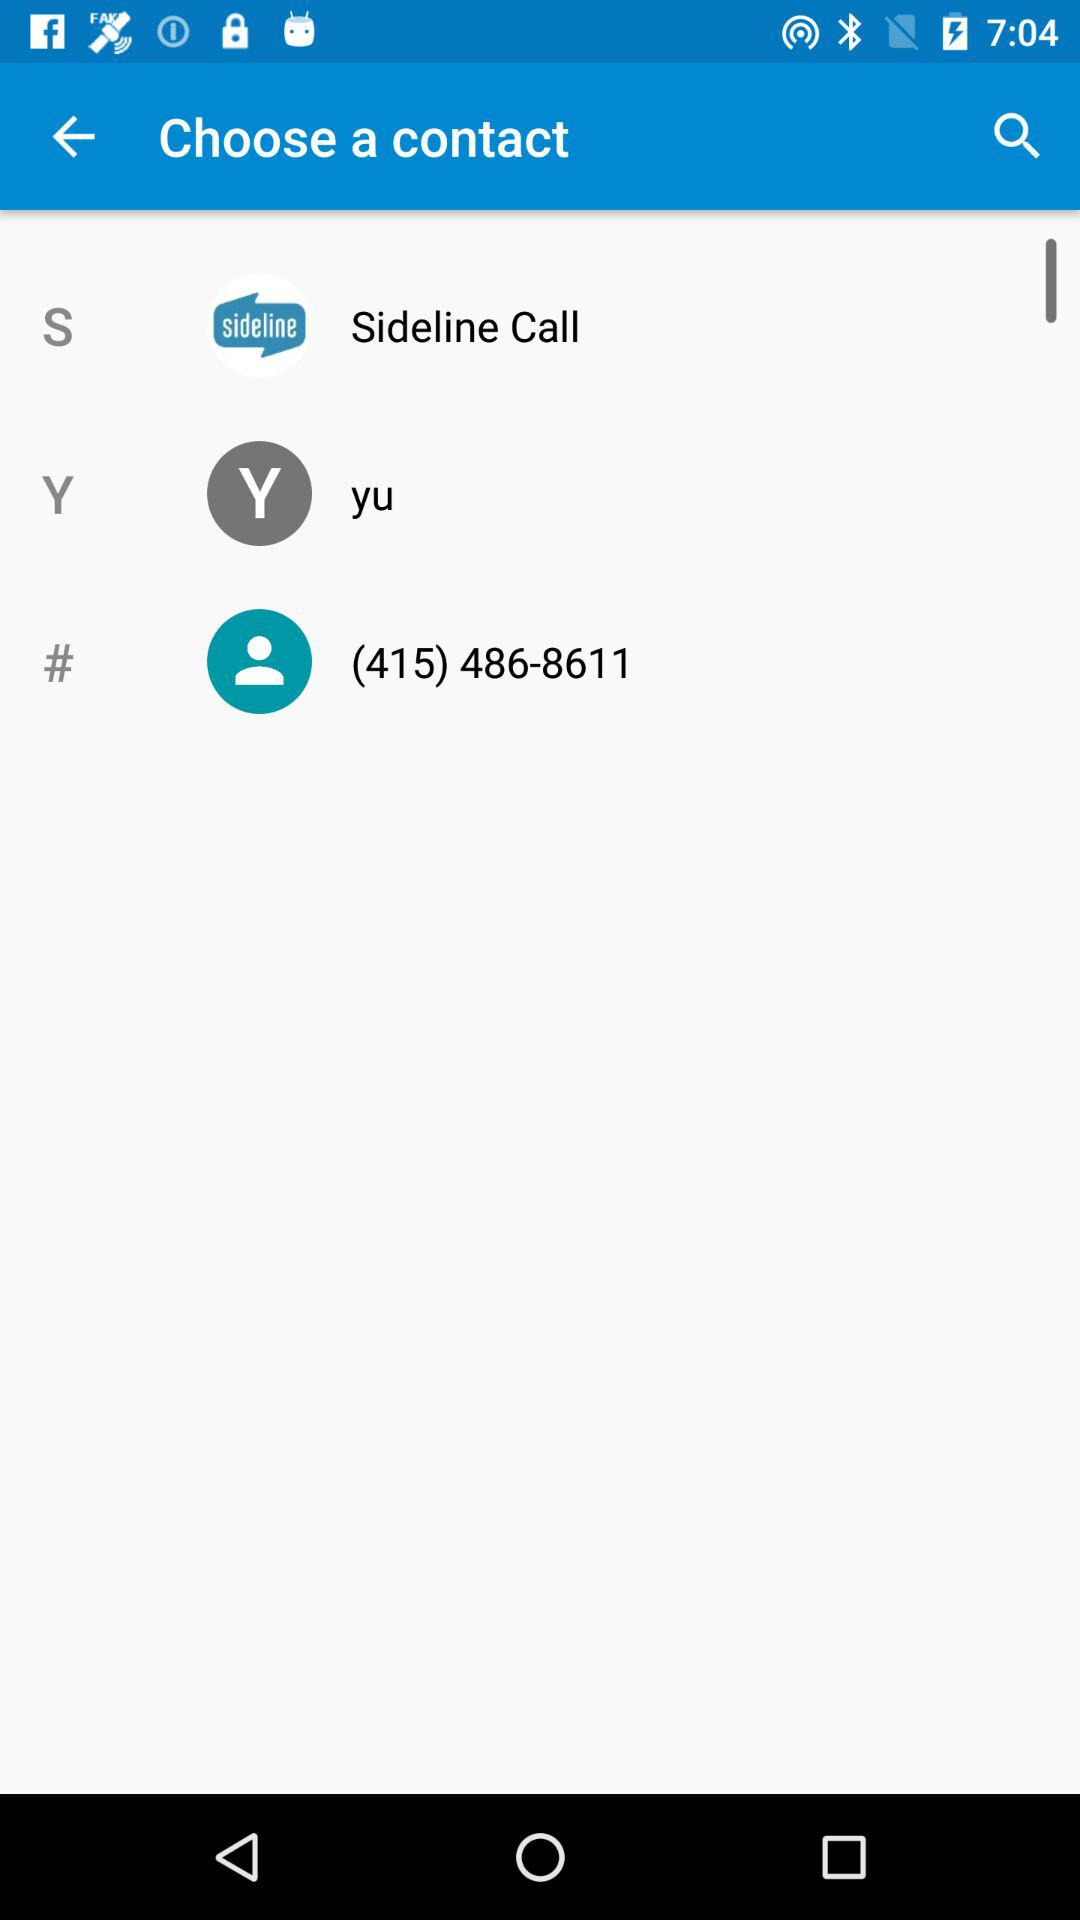What is the contact number? The contact number is (415) 486-8611. 